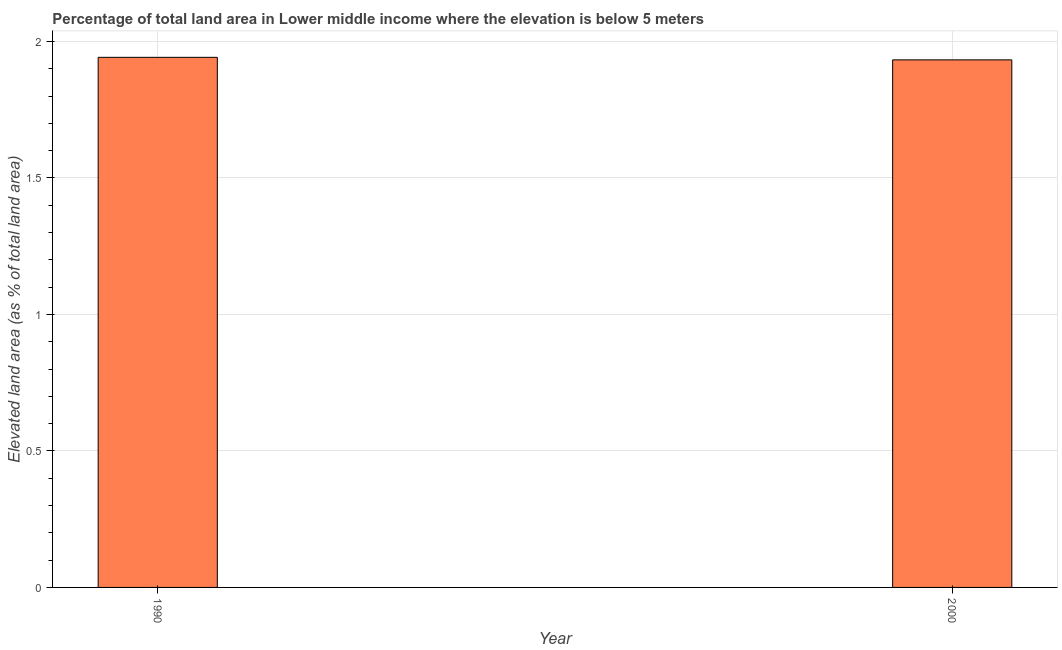Does the graph contain any zero values?
Provide a short and direct response. No. What is the title of the graph?
Ensure brevity in your answer.  Percentage of total land area in Lower middle income where the elevation is below 5 meters. What is the label or title of the X-axis?
Offer a terse response. Year. What is the label or title of the Y-axis?
Keep it short and to the point. Elevated land area (as % of total land area). What is the total elevated land area in 1990?
Give a very brief answer. 1.94. Across all years, what is the maximum total elevated land area?
Your answer should be very brief. 1.94. Across all years, what is the minimum total elevated land area?
Offer a very short reply. 1.93. What is the sum of the total elevated land area?
Provide a succinct answer. 3.87. What is the difference between the total elevated land area in 1990 and 2000?
Offer a terse response. 0.01. What is the average total elevated land area per year?
Offer a very short reply. 1.94. What is the median total elevated land area?
Your answer should be very brief. 1.94. In how many years, is the total elevated land area greater than 1.8 %?
Make the answer very short. 2. Do a majority of the years between 1990 and 2000 (inclusive) have total elevated land area greater than 1.4 %?
Give a very brief answer. Yes. How many bars are there?
Your answer should be very brief. 2. Are all the bars in the graph horizontal?
Make the answer very short. No. What is the difference between two consecutive major ticks on the Y-axis?
Give a very brief answer. 0.5. Are the values on the major ticks of Y-axis written in scientific E-notation?
Your response must be concise. No. What is the Elevated land area (as % of total land area) of 1990?
Provide a short and direct response. 1.94. What is the Elevated land area (as % of total land area) of 2000?
Provide a short and direct response. 1.93. What is the difference between the Elevated land area (as % of total land area) in 1990 and 2000?
Offer a very short reply. 0.01. What is the ratio of the Elevated land area (as % of total land area) in 1990 to that in 2000?
Ensure brevity in your answer.  1. 